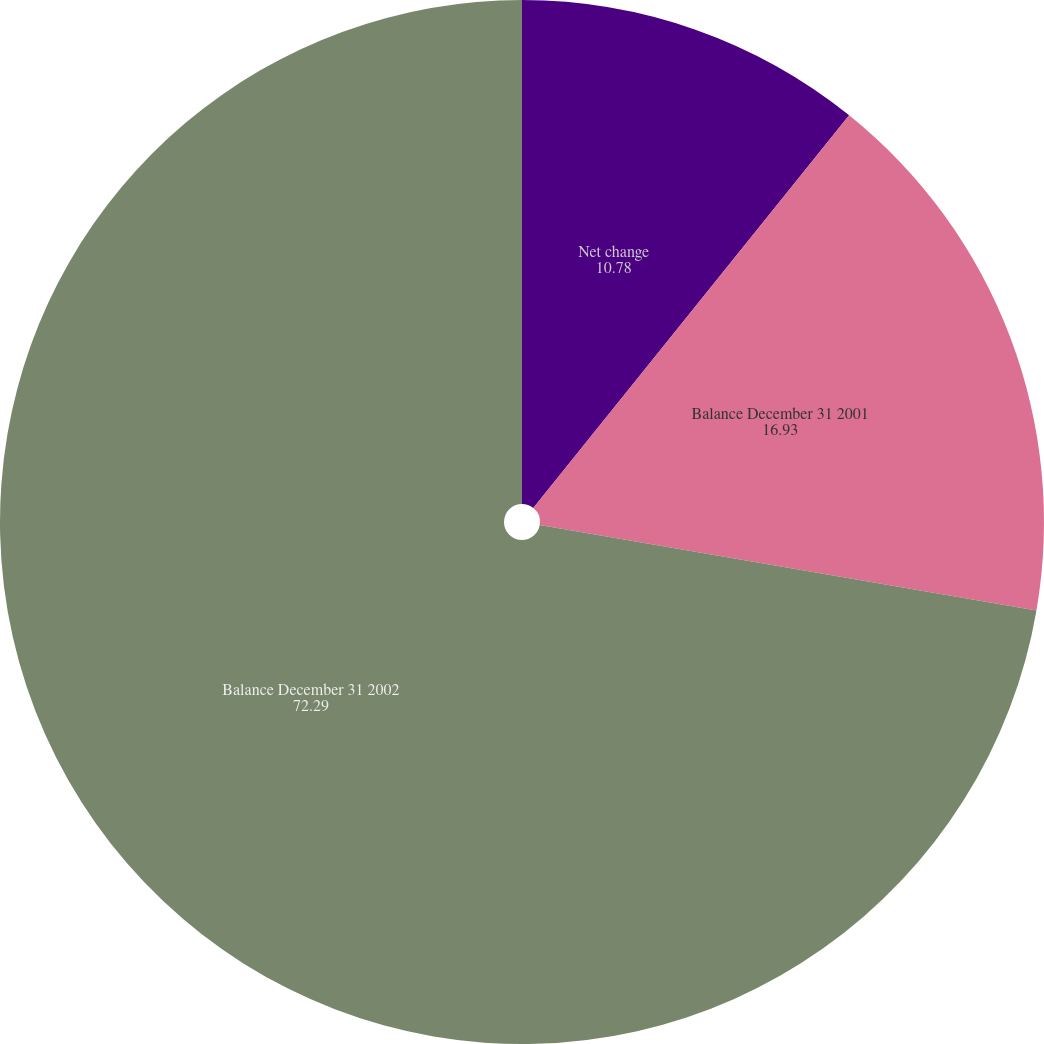Convert chart to OTSL. <chart><loc_0><loc_0><loc_500><loc_500><pie_chart><fcel>Net change<fcel>Balance December 31 2001<fcel>Balance December 31 2002<nl><fcel>10.78%<fcel>16.93%<fcel>72.29%<nl></chart> 